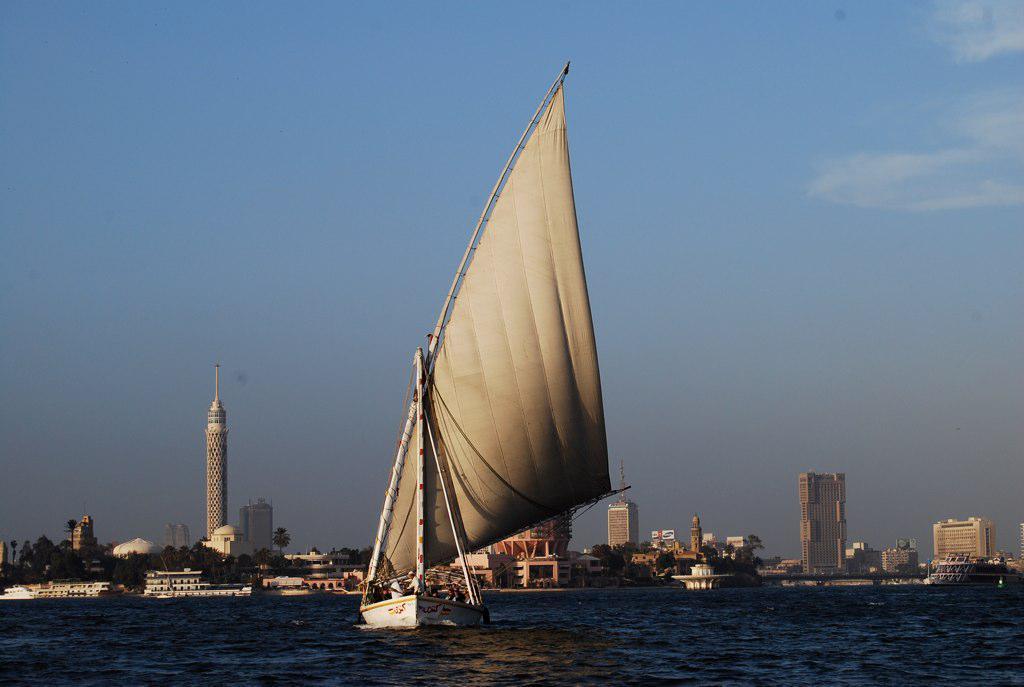Please provide a concise description of this image. In this image I can see the boat on the water. In the background I can see the trees and many buildings. I can also see the sky in the back. 